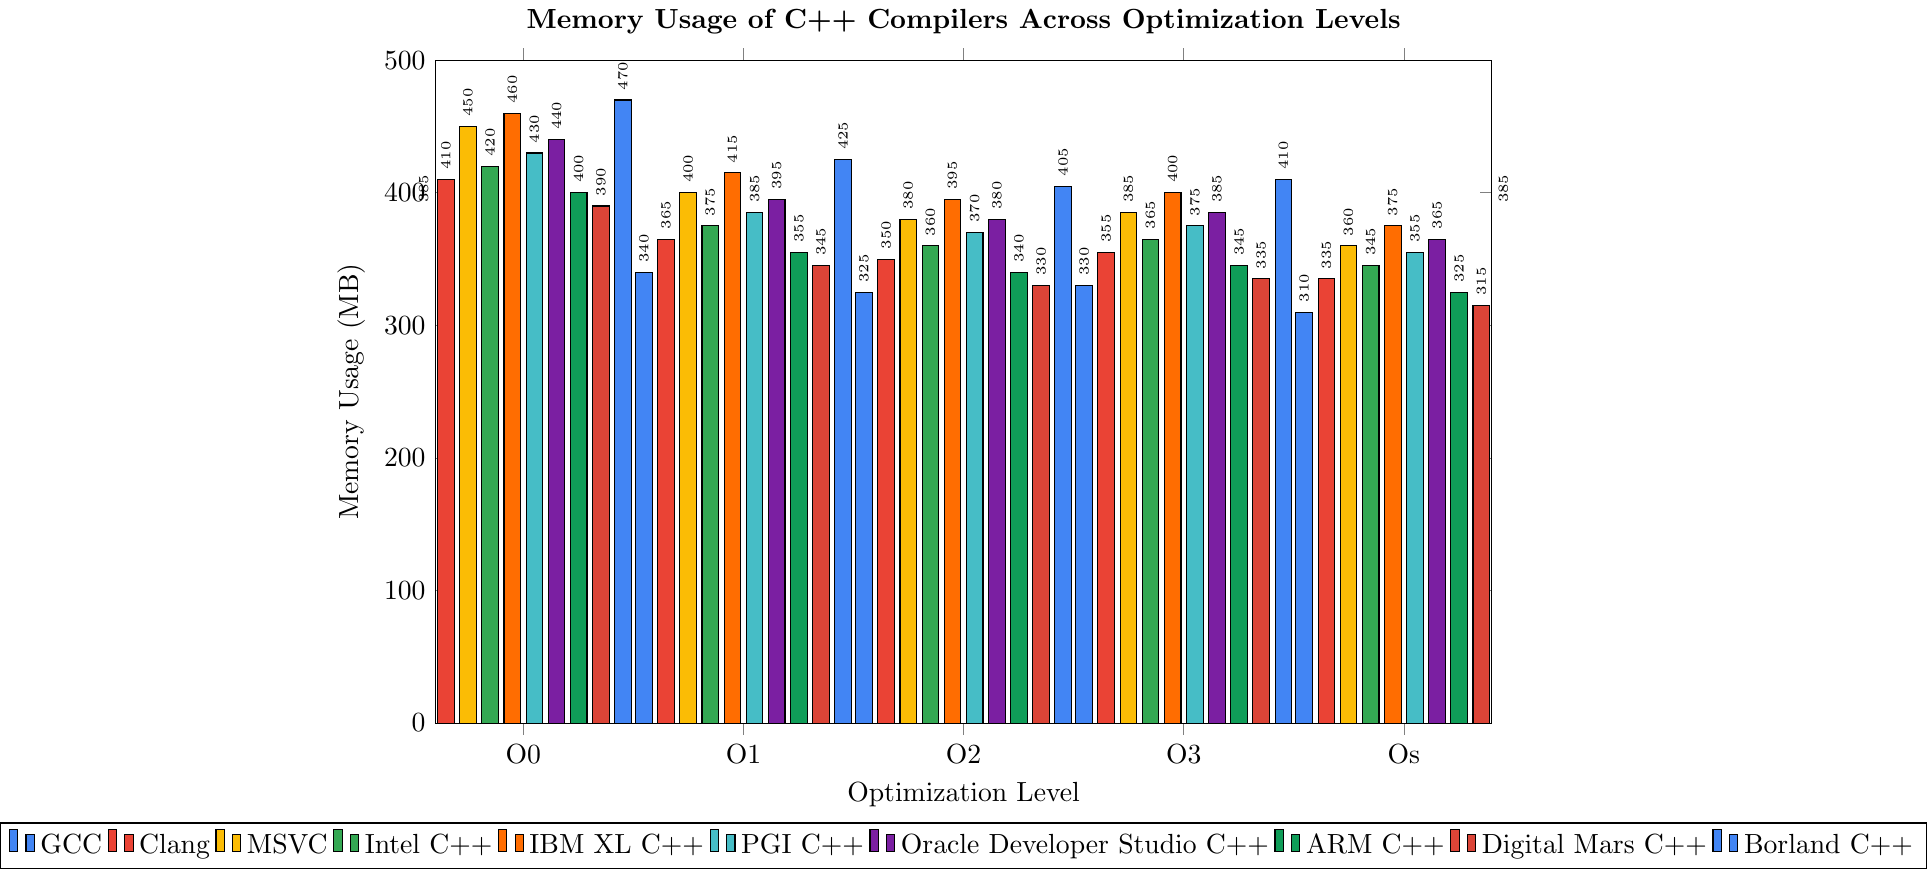What is the compiler with the highest memory usage at O0 optimization level? Look for the bar with the highest height in the O0 category. The tallest bar represents Borland C++ with a value of 470 MB.
Answer: Borland C++ Which compiler shows the least memory usage at Os optimization level? Look for the shortest bar in the Os category. The shortest bar represents GCC with a value of 310 MB.
Answer: GCC What's the average memory usage at O2 optimization level across all compilers? Sum the memory usage values for O2 across all compilers and divide by the number of compilers. (325 + 350 + 380 + 360 + 395 + 370 + 380 + 340 + 330 + 405) / 10 = 363.5 MB.
Answer: 363.5 MB Compare the memory usage between Clang and MSVC at O3 optimization level. Which one is higher and by how much? Look at the height of the bars for Clang and MSVC at O3. Clang has 355 MB and MSVC has 385 MB. MSVC is higher by 30 MB.
Answer: MSVC by 30 MB Which compiler has the smallest difference in memory usage between O1 and O2 optimization levels? Calculate the difference in memory usage between O1 and O2 for each compiler and determine the smallest one. GCC: 15 MB, Clang: 15 MB, MSVC: 20 MB, Intel C++: 15 MB, IBM XL C++: 20 MB, PGI C++: 15 MB, Oracle Developer Studio C++: 15 MB, ARM C++: 15 MB, Digital Mars C++: 15 MB, Borland C++: 20 MB. The smallest difference is 15 MB.
Answer: GCC, Clang, Intel C++, PGI C++, Oracle Developer Studio C++, ARM C++, Digital Mars C++ What is the total memory usage for PGI C++ compiler across all optimization levels? Sum the memory usage values for PGI C++ across all optimization levels. 430 + 385 + 370 + 375 + 355 = 1915 MB.
Answer: 1915 MB Which compiler has the highest drop in memory usage from O0 to Os optimization level? Calculate the difference in memory usage from O0 to Os for each compiler and determine the highest drop. GCC: 75 MB, Clang: 75 MB, MSVC: 90 MB, Intel C++: 75 MB, IBM XL C++: 85 MB, PGI C++: 75 MB, Oracle Developer Studio C++: 75 MB, ARM C++: 75 MB, Digital Mars C++: 75 MB, Borland C++: 85 MB. The highest drop is 90 MB.
Answer: MSVC 